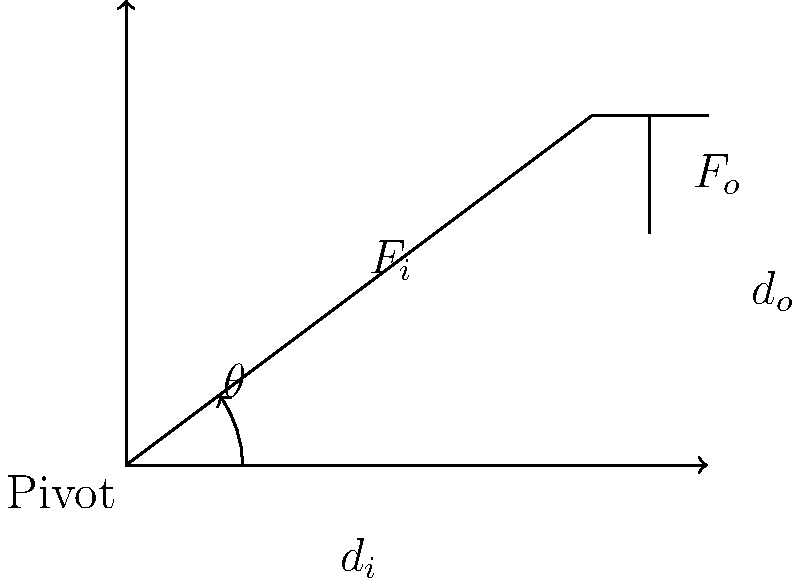In the trebuchet catapult shown, the input force $F_i$ is applied at a distance $d_i$ from the pivot, while the output force $F_o$ acts on the projectile at a distance $d_o$ from the pivot. The arm makes an angle $\theta$ with the horizontal. If $F_i = 1000$ N, $d_i = 2$ m, $d_o = 8$ m, and $\theta = 37°$, calculate the magnitude of the output force $F_o$. To solve this problem, we'll use the principle of moments and the mechanical advantage of the lever system:

1) The trebuchet operates as a first-class lever, where the pivot is between the input and output forces.

2) For equilibrium, the sum of moments about the pivot must be zero:
   $$F_i \cdot d_i = F_o \cdot d_o$$

3) Rearranging this equation to solve for $F_o$:
   $$F_o = \frac{F_i \cdot d_i}{d_o}$$

4) Substituting the given values:
   $$F_o = \frac{1000 \text{ N} \cdot 2 \text{ m}}{8 \text{ m}}$$

5) Calculating:
   $$F_o = 250 \text{ N}$$

6) Note: The angle $\theta$ doesn't affect this calculation because we're considering the perpendicular distances from the pivot to the force lines.

7) However, in a real trebuchet, this angle would affect the trajectory of the projectile and the efficiency of the energy transfer.
Answer: 250 N 